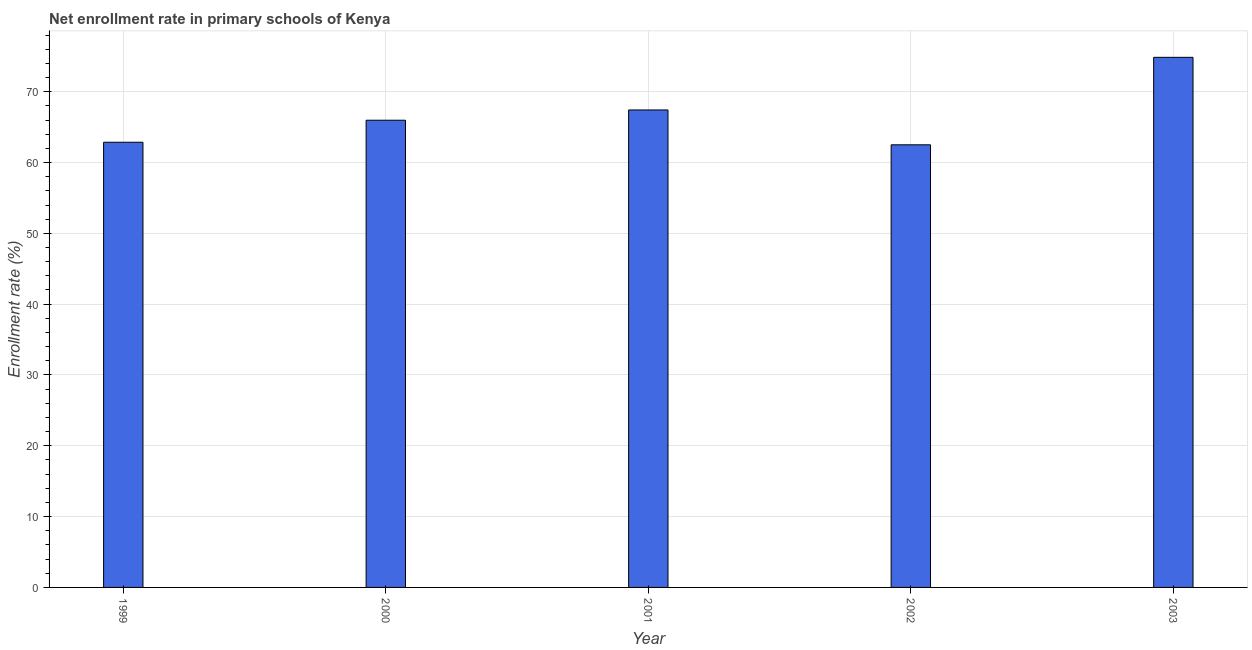What is the title of the graph?
Give a very brief answer. Net enrollment rate in primary schools of Kenya. What is the label or title of the Y-axis?
Provide a succinct answer. Enrollment rate (%). What is the net enrollment rate in primary schools in 2002?
Give a very brief answer. 62.5. Across all years, what is the maximum net enrollment rate in primary schools?
Give a very brief answer. 74.85. Across all years, what is the minimum net enrollment rate in primary schools?
Your answer should be compact. 62.5. What is the sum of the net enrollment rate in primary schools?
Provide a succinct answer. 333.61. What is the difference between the net enrollment rate in primary schools in 2000 and 2003?
Provide a short and direct response. -8.88. What is the average net enrollment rate in primary schools per year?
Keep it short and to the point. 66.72. What is the median net enrollment rate in primary schools?
Provide a succinct answer. 65.97. What is the ratio of the net enrollment rate in primary schools in 2001 to that in 2002?
Your answer should be compact. 1.08. Is the net enrollment rate in primary schools in 1999 less than that in 2003?
Make the answer very short. Yes. Is the difference between the net enrollment rate in primary schools in 1999 and 2001 greater than the difference between any two years?
Offer a very short reply. No. What is the difference between the highest and the second highest net enrollment rate in primary schools?
Your answer should be very brief. 7.43. Is the sum of the net enrollment rate in primary schools in 2002 and 2003 greater than the maximum net enrollment rate in primary schools across all years?
Keep it short and to the point. Yes. What is the difference between the highest and the lowest net enrollment rate in primary schools?
Your answer should be compact. 12.35. How many bars are there?
Give a very brief answer. 5. Are the values on the major ticks of Y-axis written in scientific E-notation?
Your answer should be compact. No. What is the Enrollment rate (%) of 1999?
Make the answer very short. 62.86. What is the Enrollment rate (%) of 2000?
Your answer should be very brief. 65.97. What is the Enrollment rate (%) of 2001?
Make the answer very short. 67.42. What is the Enrollment rate (%) in 2002?
Ensure brevity in your answer.  62.5. What is the Enrollment rate (%) of 2003?
Make the answer very short. 74.85. What is the difference between the Enrollment rate (%) in 1999 and 2000?
Your answer should be very brief. -3.11. What is the difference between the Enrollment rate (%) in 1999 and 2001?
Ensure brevity in your answer.  -4.56. What is the difference between the Enrollment rate (%) in 1999 and 2002?
Offer a terse response. 0.36. What is the difference between the Enrollment rate (%) in 1999 and 2003?
Your response must be concise. -11.99. What is the difference between the Enrollment rate (%) in 2000 and 2001?
Ensure brevity in your answer.  -1.45. What is the difference between the Enrollment rate (%) in 2000 and 2002?
Make the answer very short. 3.47. What is the difference between the Enrollment rate (%) in 2000 and 2003?
Provide a short and direct response. -8.88. What is the difference between the Enrollment rate (%) in 2001 and 2002?
Make the answer very short. 4.92. What is the difference between the Enrollment rate (%) in 2001 and 2003?
Your response must be concise. -7.43. What is the difference between the Enrollment rate (%) in 2002 and 2003?
Make the answer very short. -12.35. What is the ratio of the Enrollment rate (%) in 1999 to that in 2000?
Ensure brevity in your answer.  0.95. What is the ratio of the Enrollment rate (%) in 1999 to that in 2001?
Your response must be concise. 0.93. What is the ratio of the Enrollment rate (%) in 1999 to that in 2003?
Offer a very short reply. 0.84. What is the ratio of the Enrollment rate (%) in 2000 to that in 2002?
Keep it short and to the point. 1.06. What is the ratio of the Enrollment rate (%) in 2000 to that in 2003?
Keep it short and to the point. 0.88. What is the ratio of the Enrollment rate (%) in 2001 to that in 2002?
Ensure brevity in your answer.  1.08. What is the ratio of the Enrollment rate (%) in 2001 to that in 2003?
Offer a very short reply. 0.9. What is the ratio of the Enrollment rate (%) in 2002 to that in 2003?
Offer a terse response. 0.83. 